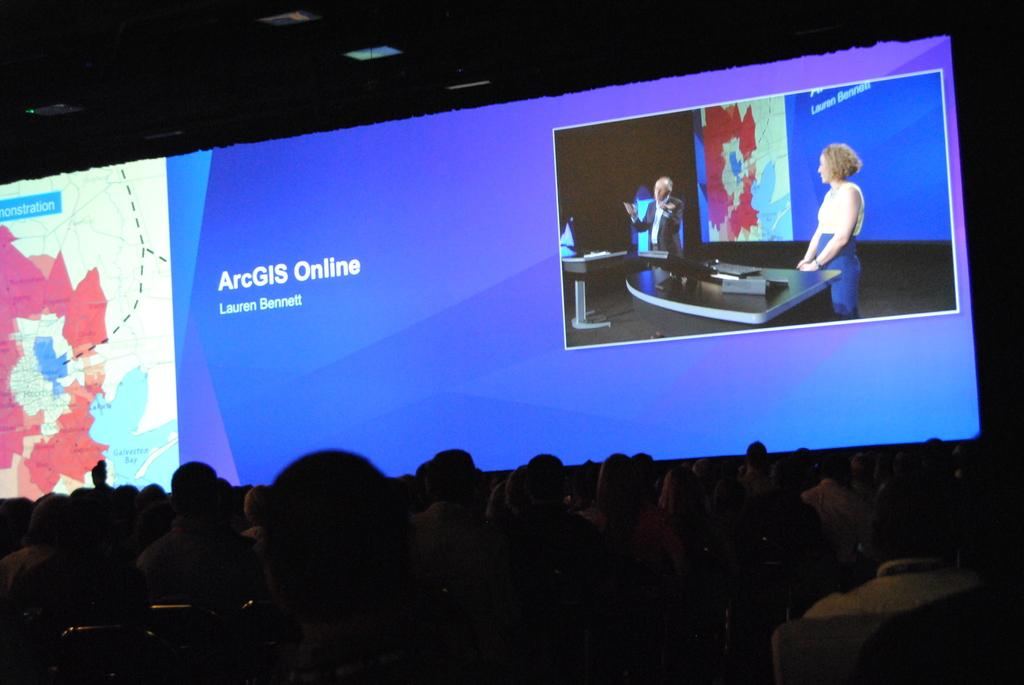<image>
Share a concise interpretation of the image provided. A screen displayed before an audience has the text "ArcGIS Online" on it. 